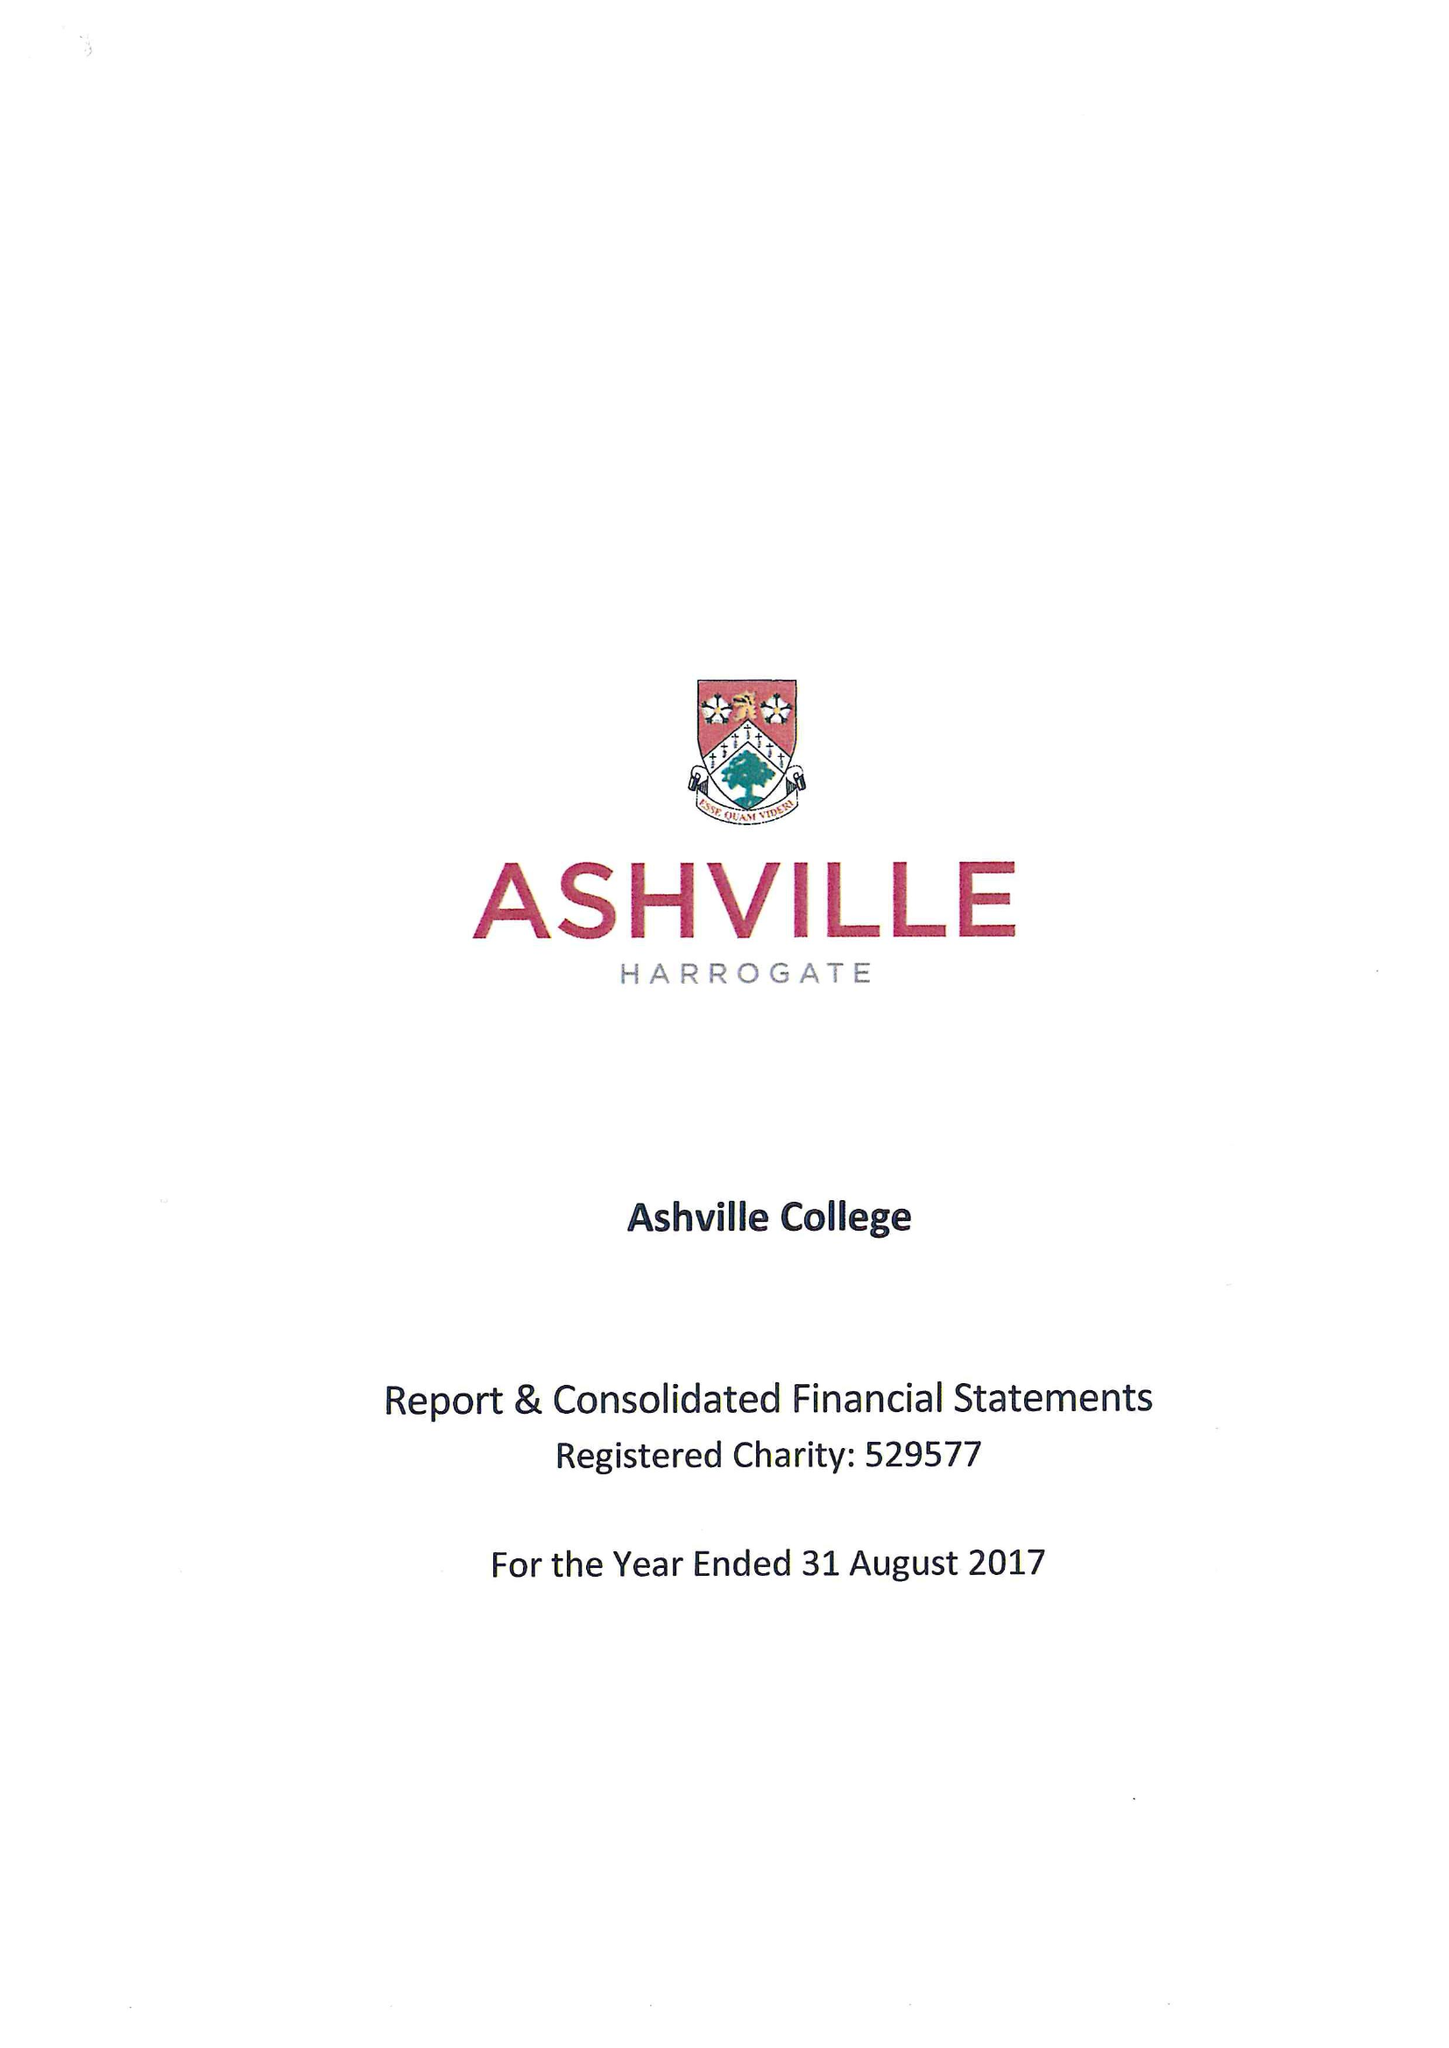What is the value for the address__street_line?
Answer the question using a single word or phrase. GREEN LANE 